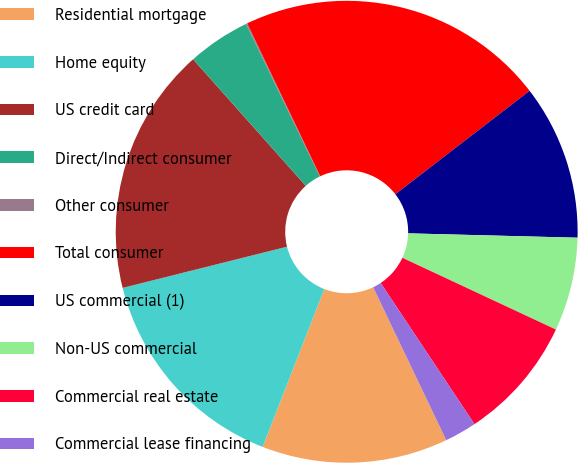Convert chart. <chart><loc_0><loc_0><loc_500><loc_500><pie_chart><fcel>Residential mortgage<fcel>Home equity<fcel>US credit card<fcel>Direct/Indirect consumer<fcel>Other consumer<fcel>Total consumer<fcel>US commercial (1)<fcel>Non-US commercial<fcel>Commercial real estate<fcel>Commercial lease financing<nl><fcel>13.02%<fcel>15.17%<fcel>17.33%<fcel>4.4%<fcel>0.09%<fcel>21.64%<fcel>10.86%<fcel>6.55%<fcel>8.71%<fcel>2.24%<nl></chart> 